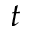Convert formula to latex. <formula><loc_0><loc_0><loc_500><loc_500>t</formula> 